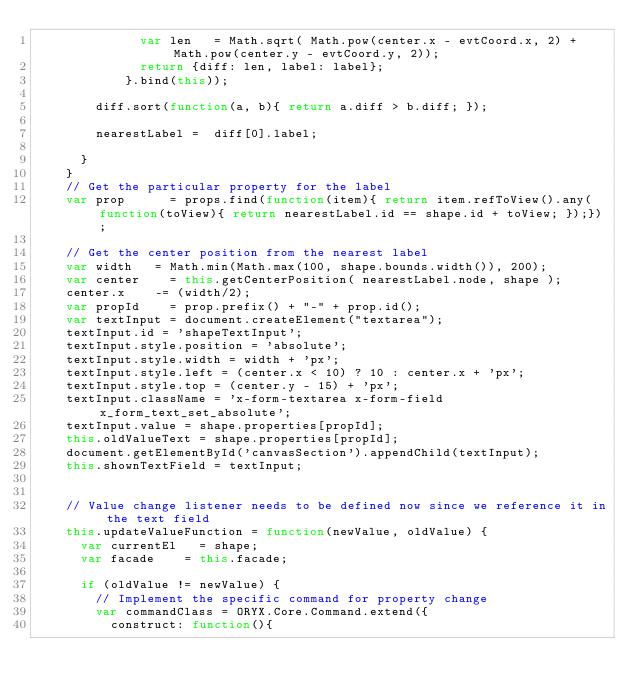<code> <loc_0><loc_0><loc_500><loc_500><_JavaScript_>							var len 	= Math.sqrt( Math.pow(center.x - evtCoord.x, 2) + Math.pow(center.y - evtCoord.y, 2));
							return {diff: len, label: label}; 
						}.bind(this));
				
				diff.sort(function(a, b){ return a.diff > b.diff; });
				
				nearestLabel = 	diff[0].label;

			}
		}
		// Get the particular property for the label
		var prop 			= props.find(function(item){ return item.refToView().any(function(toView){ return nearestLabel.id == shape.id + toView; });});
		
		// Get the center position from the nearest label
		var width		= Math.min(Math.max(100, shape.bounds.width()), 200);
		var center 		= this.getCenterPosition( nearestLabel.node, shape );
		center.x		-= (width/2);
		var propId		= prop.prefix() + "-" + prop.id();
		var textInput = document.createElement("textarea");
		textInput.id = 'shapeTextInput';
		textInput.style.position = 'absolute';
		textInput.style.width = width + 'px';
		textInput.style.left = (center.x < 10) ? 10 : center.x + 'px';
		textInput.style.top = (center.y - 15) + 'px';
		textInput.className = 'x-form-textarea x-form-field x_form_text_set_absolute';
		textInput.value = shape.properties[propId];
		this.oldValueText = shape.properties[propId];
		document.getElementById('canvasSection').appendChild(textInput);
		this.shownTextField = textInput;
		
		
		// Value change listener needs to be defined now since we reference it in the text field
		this.updateValueFunction = function(newValue, oldValue) {
			var currentEl 	= shape;
			var facade		= this.facade;
			
			if (oldValue != newValue) {
				// Implement the specific command for property change
				var commandClass = ORYX.Core.Command.extend({
					construct: function(){</code> 